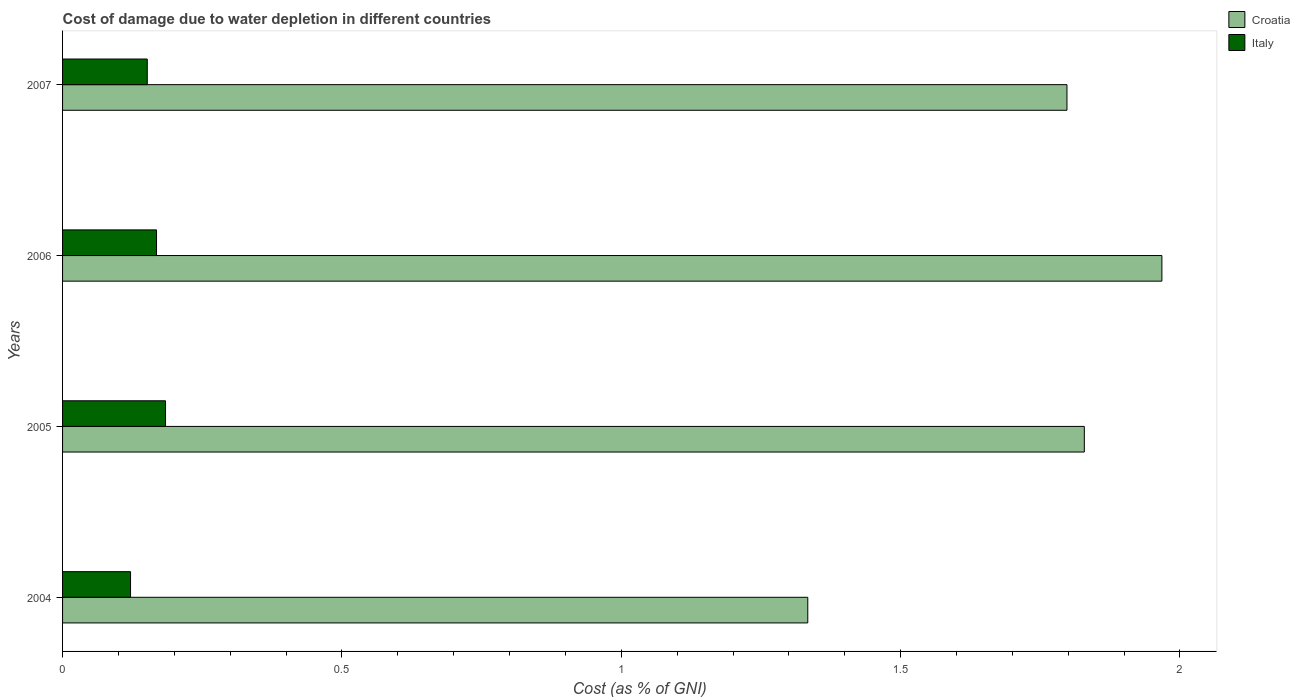How many groups of bars are there?
Make the answer very short. 4. Are the number of bars per tick equal to the number of legend labels?
Ensure brevity in your answer.  Yes. Are the number of bars on each tick of the Y-axis equal?
Your answer should be compact. Yes. How many bars are there on the 4th tick from the bottom?
Your answer should be compact. 2. In how many cases, is the number of bars for a given year not equal to the number of legend labels?
Your answer should be compact. 0. What is the cost of damage caused due to water depletion in Croatia in 2004?
Offer a very short reply. 1.33. Across all years, what is the maximum cost of damage caused due to water depletion in Croatia?
Make the answer very short. 1.97. Across all years, what is the minimum cost of damage caused due to water depletion in Italy?
Your answer should be compact. 0.12. In which year was the cost of damage caused due to water depletion in Italy maximum?
Your answer should be very brief. 2005. In which year was the cost of damage caused due to water depletion in Croatia minimum?
Provide a short and direct response. 2004. What is the total cost of damage caused due to water depletion in Croatia in the graph?
Your answer should be compact. 6.93. What is the difference between the cost of damage caused due to water depletion in Italy in 2004 and that in 2005?
Your answer should be compact. -0.06. What is the difference between the cost of damage caused due to water depletion in Italy in 2006 and the cost of damage caused due to water depletion in Croatia in 2005?
Your answer should be compact. -1.66. What is the average cost of damage caused due to water depletion in Italy per year?
Ensure brevity in your answer.  0.16. In the year 2006, what is the difference between the cost of damage caused due to water depletion in Italy and cost of damage caused due to water depletion in Croatia?
Provide a short and direct response. -1.8. What is the ratio of the cost of damage caused due to water depletion in Italy in 2004 to that in 2005?
Offer a terse response. 0.66. Is the difference between the cost of damage caused due to water depletion in Italy in 2004 and 2005 greater than the difference between the cost of damage caused due to water depletion in Croatia in 2004 and 2005?
Ensure brevity in your answer.  Yes. What is the difference between the highest and the second highest cost of damage caused due to water depletion in Croatia?
Provide a succinct answer. 0.14. What is the difference between the highest and the lowest cost of damage caused due to water depletion in Croatia?
Keep it short and to the point. 0.63. Is the sum of the cost of damage caused due to water depletion in Italy in 2005 and 2006 greater than the maximum cost of damage caused due to water depletion in Croatia across all years?
Your answer should be very brief. No. What does the 2nd bar from the top in 2005 represents?
Offer a very short reply. Croatia. What does the 2nd bar from the bottom in 2005 represents?
Your response must be concise. Italy. How many years are there in the graph?
Make the answer very short. 4. What is the difference between two consecutive major ticks on the X-axis?
Ensure brevity in your answer.  0.5. Are the values on the major ticks of X-axis written in scientific E-notation?
Offer a terse response. No. Does the graph contain grids?
Your answer should be very brief. No. Where does the legend appear in the graph?
Give a very brief answer. Top right. How many legend labels are there?
Offer a very short reply. 2. What is the title of the graph?
Make the answer very short. Cost of damage due to water depletion in different countries. Does "Hungary" appear as one of the legend labels in the graph?
Your answer should be compact. No. What is the label or title of the X-axis?
Your answer should be compact. Cost (as % of GNI). What is the Cost (as % of GNI) in Croatia in 2004?
Offer a terse response. 1.33. What is the Cost (as % of GNI) in Italy in 2004?
Give a very brief answer. 0.12. What is the Cost (as % of GNI) in Croatia in 2005?
Keep it short and to the point. 1.83. What is the Cost (as % of GNI) of Italy in 2005?
Your answer should be compact. 0.18. What is the Cost (as % of GNI) in Croatia in 2006?
Keep it short and to the point. 1.97. What is the Cost (as % of GNI) of Italy in 2006?
Ensure brevity in your answer.  0.17. What is the Cost (as % of GNI) in Croatia in 2007?
Your answer should be very brief. 1.8. What is the Cost (as % of GNI) of Italy in 2007?
Offer a terse response. 0.15. Across all years, what is the maximum Cost (as % of GNI) of Croatia?
Your answer should be compact. 1.97. Across all years, what is the maximum Cost (as % of GNI) in Italy?
Provide a short and direct response. 0.18. Across all years, what is the minimum Cost (as % of GNI) in Croatia?
Ensure brevity in your answer.  1.33. Across all years, what is the minimum Cost (as % of GNI) of Italy?
Give a very brief answer. 0.12. What is the total Cost (as % of GNI) of Croatia in the graph?
Make the answer very short. 6.93. What is the total Cost (as % of GNI) in Italy in the graph?
Give a very brief answer. 0.63. What is the difference between the Cost (as % of GNI) of Croatia in 2004 and that in 2005?
Keep it short and to the point. -0.49. What is the difference between the Cost (as % of GNI) in Italy in 2004 and that in 2005?
Give a very brief answer. -0.06. What is the difference between the Cost (as % of GNI) of Croatia in 2004 and that in 2006?
Your answer should be very brief. -0.63. What is the difference between the Cost (as % of GNI) of Italy in 2004 and that in 2006?
Provide a short and direct response. -0.05. What is the difference between the Cost (as % of GNI) of Croatia in 2004 and that in 2007?
Provide a short and direct response. -0.46. What is the difference between the Cost (as % of GNI) of Italy in 2004 and that in 2007?
Provide a succinct answer. -0.03. What is the difference between the Cost (as % of GNI) of Croatia in 2005 and that in 2006?
Provide a short and direct response. -0.14. What is the difference between the Cost (as % of GNI) of Italy in 2005 and that in 2006?
Make the answer very short. 0.02. What is the difference between the Cost (as % of GNI) in Croatia in 2005 and that in 2007?
Your answer should be compact. 0.03. What is the difference between the Cost (as % of GNI) of Italy in 2005 and that in 2007?
Keep it short and to the point. 0.03. What is the difference between the Cost (as % of GNI) in Croatia in 2006 and that in 2007?
Keep it short and to the point. 0.17. What is the difference between the Cost (as % of GNI) in Italy in 2006 and that in 2007?
Your response must be concise. 0.02. What is the difference between the Cost (as % of GNI) of Croatia in 2004 and the Cost (as % of GNI) of Italy in 2005?
Provide a short and direct response. 1.15. What is the difference between the Cost (as % of GNI) of Croatia in 2004 and the Cost (as % of GNI) of Italy in 2006?
Provide a succinct answer. 1.17. What is the difference between the Cost (as % of GNI) in Croatia in 2004 and the Cost (as % of GNI) in Italy in 2007?
Ensure brevity in your answer.  1.18. What is the difference between the Cost (as % of GNI) in Croatia in 2005 and the Cost (as % of GNI) in Italy in 2006?
Your response must be concise. 1.66. What is the difference between the Cost (as % of GNI) in Croatia in 2005 and the Cost (as % of GNI) in Italy in 2007?
Give a very brief answer. 1.68. What is the difference between the Cost (as % of GNI) in Croatia in 2006 and the Cost (as % of GNI) in Italy in 2007?
Your answer should be compact. 1.82. What is the average Cost (as % of GNI) of Croatia per year?
Your answer should be compact. 1.73. What is the average Cost (as % of GNI) of Italy per year?
Provide a succinct answer. 0.16. In the year 2004, what is the difference between the Cost (as % of GNI) in Croatia and Cost (as % of GNI) in Italy?
Provide a succinct answer. 1.21. In the year 2005, what is the difference between the Cost (as % of GNI) of Croatia and Cost (as % of GNI) of Italy?
Give a very brief answer. 1.64. In the year 2006, what is the difference between the Cost (as % of GNI) of Croatia and Cost (as % of GNI) of Italy?
Provide a succinct answer. 1.8. In the year 2007, what is the difference between the Cost (as % of GNI) of Croatia and Cost (as % of GNI) of Italy?
Ensure brevity in your answer.  1.65. What is the ratio of the Cost (as % of GNI) in Croatia in 2004 to that in 2005?
Make the answer very short. 0.73. What is the ratio of the Cost (as % of GNI) in Italy in 2004 to that in 2005?
Make the answer very short. 0.66. What is the ratio of the Cost (as % of GNI) in Croatia in 2004 to that in 2006?
Offer a terse response. 0.68. What is the ratio of the Cost (as % of GNI) in Italy in 2004 to that in 2006?
Your answer should be compact. 0.72. What is the ratio of the Cost (as % of GNI) in Croatia in 2004 to that in 2007?
Give a very brief answer. 0.74. What is the ratio of the Cost (as % of GNI) of Italy in 2004 to that in 2007?
Give a very brief answer. 0.8. What is the ratio of the Cost (as % of GNI) of Croatia in 2005 to that in 2006?
Give a very brief answer. 0.93. What is the ratio of the Cost (as % of GNI) of Italy in 2005 to that in 2006?
Your answer should be compact. 1.1. What is the ratio of the Cost (as % of GNI) of Croatia in 2005 to that in 2007?
Ensure brevity in your answer.  1.02. What is the ratio of the Cost (as % of GNI) in Italy in 2005 to that in 2007?
Offer a terse response. 1.22. What is the ratio of the Cost (as % of GNI) in Croatia in 2006 to that in 2007?
Your answer should be very brief. 1.09. What is the ratio of the Cost (as % of GNI) in Italy in 2006 to that in 2007?
Give a very brief answer. 1.11. What is the difference between the highest and the second highest Cost (as % of GNI) of Croatia?
Give a very brief answer. 0.14. What is the difference between the highest and the second highest Cost (as % of GNI) in Italy?
Your answer should be very brief. 0.02. What is the difference between the highest and the lowest Cost (as % of GNI) of Croatia?
Keep it short and to the point. 0.63. What is the difference between the highest and the lowest Cost (as % of GNI) of Italy?
Give a very brief answer. 0.06. 